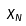Convert formula to latex. <formula><loc_0><loc_0><loc_500><loc_500>\tilde { X } _ { N }</formula> 